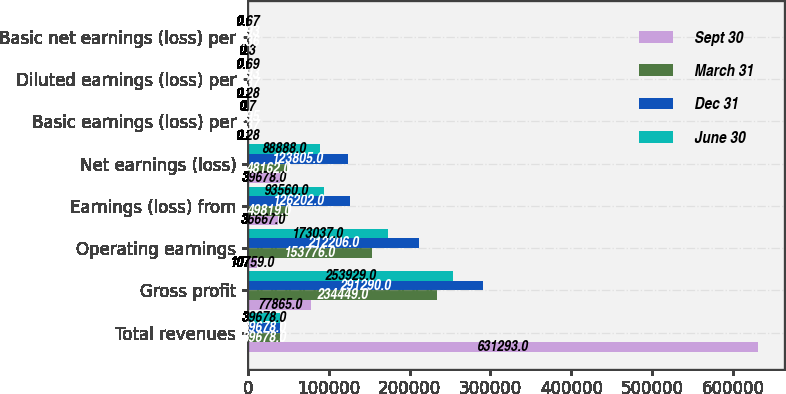Convert chart to OTSL. <chart><loc_0><loc_0><loc_500><loc_500><stacked_bar_chart><ecel><fcel>Total revenues<fcel>Gross profit<fcel>Operating earnings<fcel>Earnings (loss) from<fcel>Net earnings (loss)<fcel>Basic earnings (loss) per<fcel>Diluted earnings (loss) per<fcel>Basic net earnings (loss) per<nl><fcel>Sept 30<fcel>631293<fcel>77865<fcel>10759<fcel>36667<fcel>39678<fcel>0.28<fcel>0.28<fcel>0.3<nl><fcel>March 31<fcel>39678<fcel>234449<fcel>153776<fcel>49819<fcel>48162<fcel>0.37<fcel>0.37<fcel>0.36<nl><fcel>Dec 31<fcel>39678<fcel>291290<fcel>212206<fcel>126202<fcel>123805<fcel>0.95<fcel>0.93<fcel>0.93<nl><fcel>June 30<fcel>39678<fcel>253929<fcel>173037<fcel>93560<fcel>88888<fcel>0.7<fcel>0.69<fcel>0.67<nl></chart> 